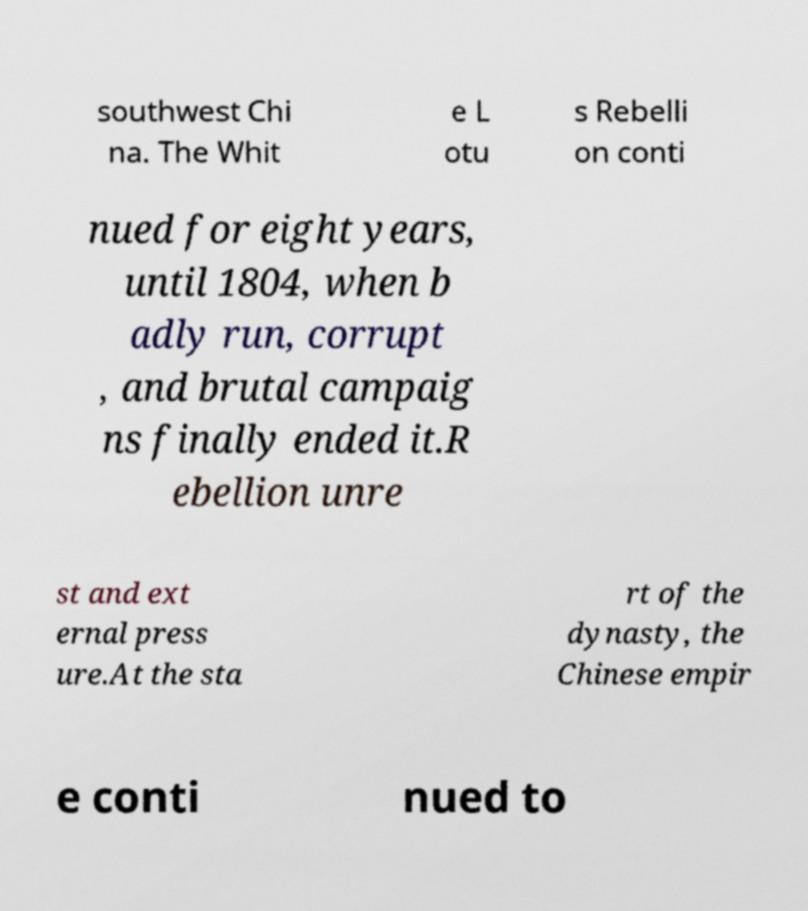Can you read and provide the text displayed in the image?This photo seems to have some interesting text. Can you extract and type it out for me? southwest Chi na. The Whit e L otu s Rebelli on conti nued for eight years, until 1804, when b adly run, corrupt , and brutal campaig ns finally ended it.R ebellion unre st and ext ernal press ure.At the sta rt of the dynasty, the Chinese empir e conti nued to 